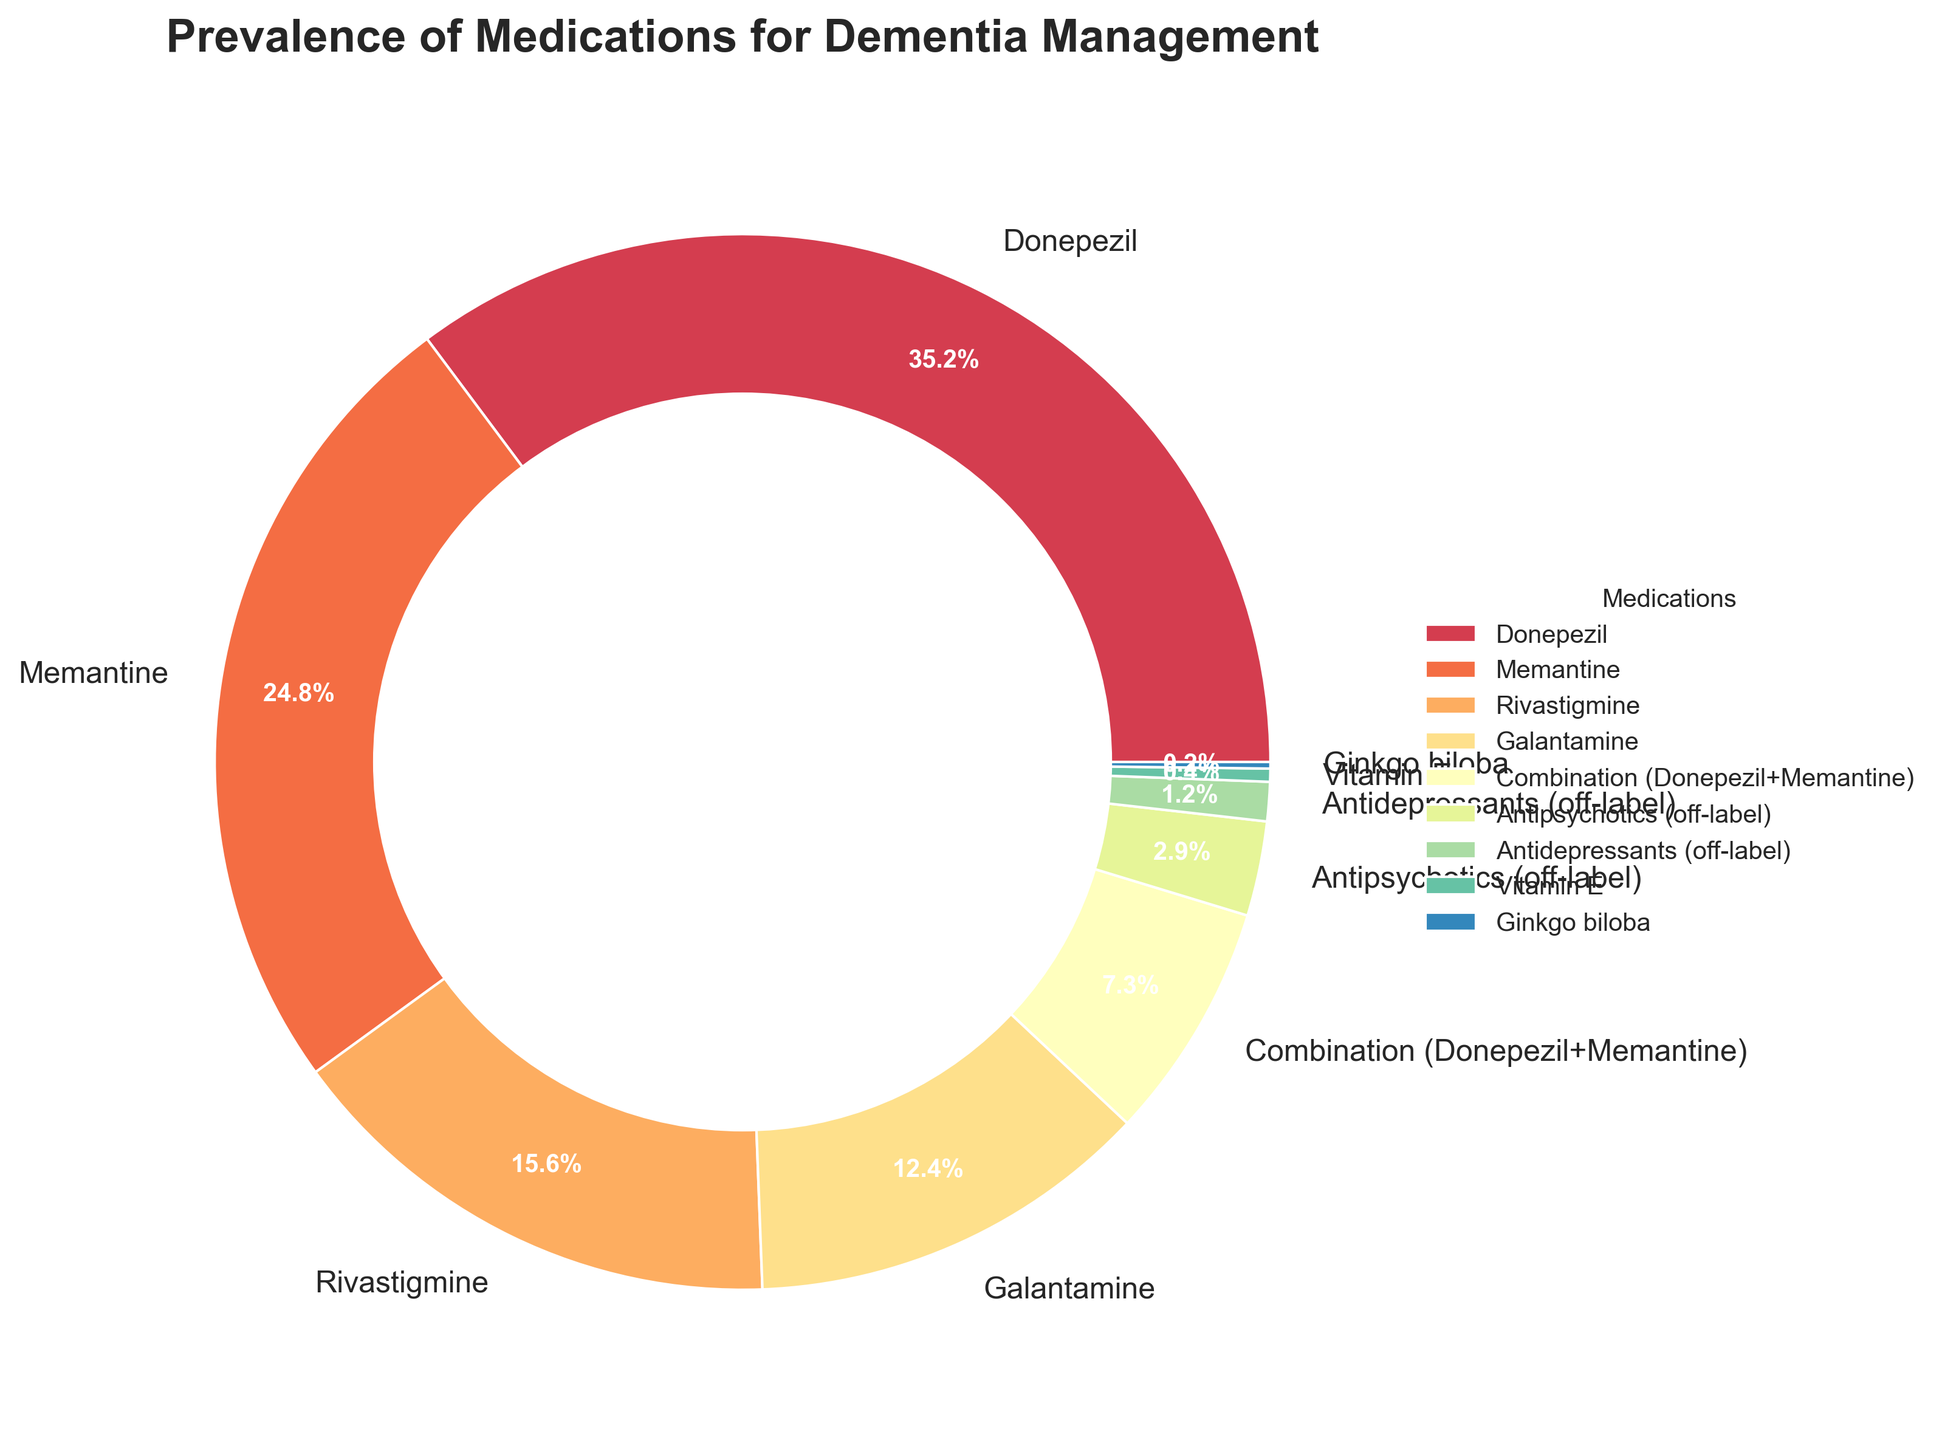What is the most commonly prescribed medication for dementia? The figure shows the medications and their respective percentages. The largest portion of the pie chart represents Donepezil, which is 35.2% of the prescribed medications.
Answer: Donepezil What percentage of prescribed medications for dementia is Donepezil combined with Memantine? The pie chart shows a segment labeled "Combination (Donepezil+Memantine)", indicating this combination accounts for 7.3% of the medications.
Answer: 7.3% How does the prevalence of Memantine compare to that of Donepezil? The pie chart shows that Memantine accounts for 24.8% while Donepezil accounts for 35.2%, indicating Donepezil is more prevalent.
Answer: Donepezil is more prevalent Which off-label use medication is more prevalent, Antipsychotics or Antidepressants? According to the pie chart, Antipsychotics (off-label) are 2.9% and Antidepressants (off-label) are 1.2%, making Antipsychotics more prevalent.
Answer: Antipsychotics What is the combined prevalence of the four leading medications for dementia management? The leading medications are Donepezil (35.2%), Memantine (24.8%), Rivastigmine (15.6%), and Galantamine (12.4%). Adding these together: 35.2 + 24.8 + 15.6 + 12.4 = 88%.
Answer: 88% How many medications are listed as having a prevalence of 1% or lower? According to the pie chart segments, Vitamin E (0.4%) and Ginkgo biloba (0.2%) have a prevalence of 1% or lower.
Answer: 2 medications What is the difference in prevalence between Rivastigmine and Galantamine? The pie chart shows Rivastigmine at 15.6% and Galantamine at 12.4%. The difference is calculated as 15.6 - 12.4 = 3.2%.
Answer: 3.2% Which medication appears in a shade of blue, and what is its percentage? The pie chart uses a custom color palette. Donepezil appears in a shade of blue and accounts for 35.2% of the medications.
Answer: Donepezil, 35.2% What portion of the pie chart is occupied by alternative treatments such as Vitamin E and Ginkgo biloba? Vitamin E is 0.4% and Ginkgo biloba is 0.2% of the pie chart. Combined, alternative treatments occupy 0.4 + 0.2 = 0.6% of the chart.
Answer: 0.6% What is the total prevalence of off-label medications used for dementia management? The off-label medications Antipsychotics (2.9%) and Antidepressants (1.2%) sum to 2.9 + 1.2 = 4.1%.
Answer: 4.1% 